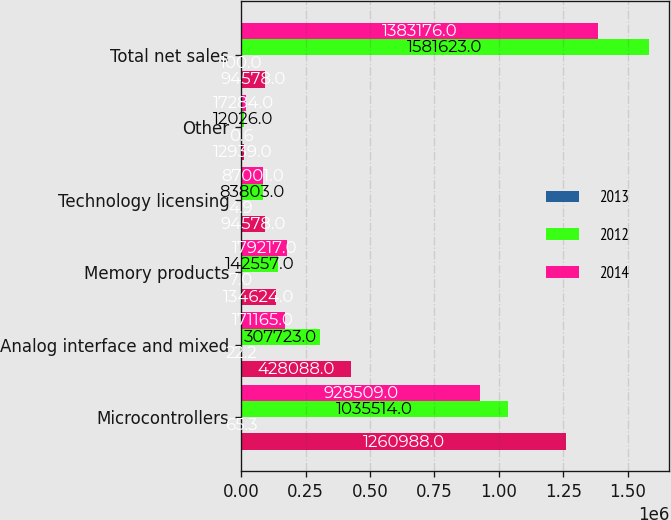Convert chart. <chart><loc_0><loc_0><loc_500><loc_500><stacked_bar_chart><ecel><fcel>Microcontrollers<fcel>Analog interface and mixed<fcel>Memory products<fcel>Technology licensing<fcel>Other<fcel>Total net sales<nl><fcel>nan<fcel>1.26099e+06<fcel>428088<fcel>134624<fcel>94578<fcel>12939<fcel>94578<nl><fcel>2013<fcel>65.3<fcel>22.2<fcel>7<fcel>4.9<fcel>0.6<fcel>100<nl><fcel>2012<fcel>1.03551e+06<fcel>307723<fcel>142557<fcel>83803<fcel>12026<fcel>1.58162e+06<nl><fcel>2014<fcel>928509<fcel>171165<fcel>179217<fcel>87001<fcel>17284<fcel>1.38318e+06<nl></chart> 